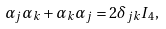<formula> <loc_0><loc_0><loc_500><loc_500>\alpha _ { j } \alpha _ { k } + \alpha _ { k } \alpha _ { j } = 2 \delta _ { j k } I _ { 4 } ,</formula> 